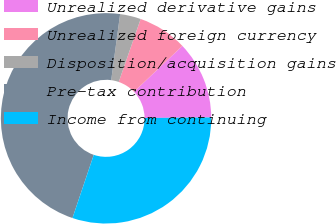Convert chart to OTSL. <chart><loc_0><loc_0><loc_500><loc_500><pie_chart><fcel>Unrealized derivative gains<fcel>Unrealized foreign currency<fcel>Disposition/acquisition gains<fcel>Pre-tax contribution<fcel>Income from continuing<nl><fcel>11.95%<fcel>7.58%<fcel>3.2%<fcel>46.96%<fcel>30.31%<nl></chart> 